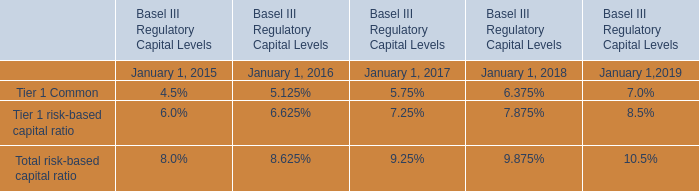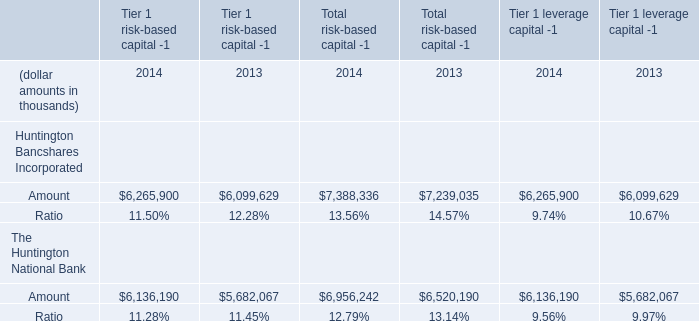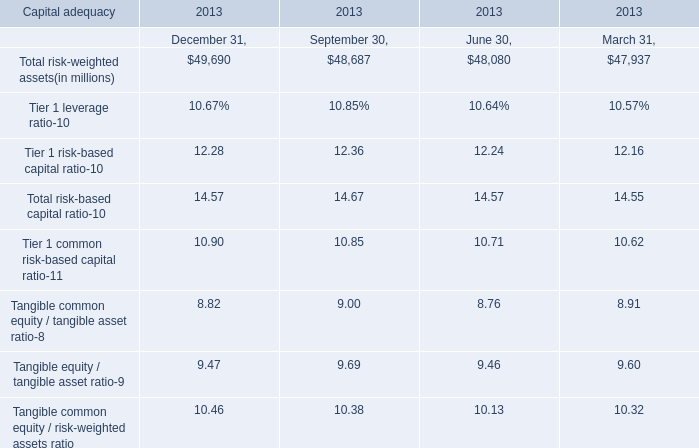What is the average amount of Total risk-weighted assets between September 30,2013 and June 30,2013? (in million) 
Computations: ((48687 + 48080) / 2)
Answer: 48383.5. 